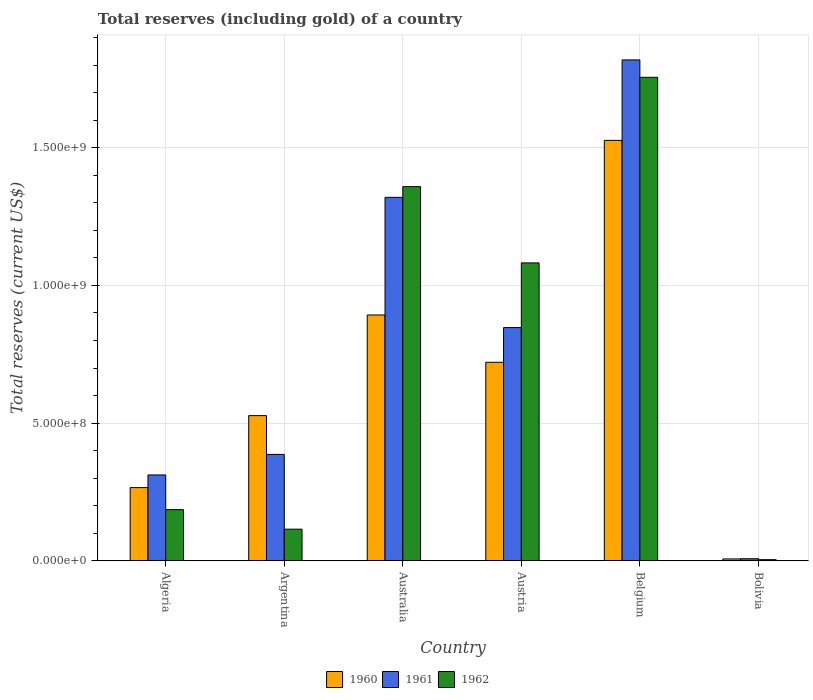How many groups of bars are there?
Your answer should be compact. 6. Are the number of bars per tick equal to the number of legend labels?
Ensure brevity in your answer.  Yes. How many bars are there on the 5th tick from the right?
Your answer should be very brief. 3. What is the label of the 1st group of bars from the left?
Make the answer very short. Algeria. In how many cases, is the number of bars for a given country not equal to the number of legend labels?
Keep it short and to the point. 0. What is the total reserves (including gold) in 1960 in Algeria?
Your response must be concise. 2.66e+08. Across all countries, what is the maximum total reserves (including gold) in 1960?
Your answer should be very brief. 1.53e+09. Across all countries, what is the minimum total reserves (including gold) in 1961?
Your answer should be very brief. 7.40e+06. What is the total total reserves (including gold) in 1962 in the graph?
Your answer should be very brief. 4.50e+09. What is the difference between the total reserves (including gold) in 1961 in Algeria and that in Austria?
Your answer should be compact. -5.35e+08. What is the difference between the total reserves (including gold) in 1962 in Argentina and the total reserves (including gold) in 1960 in Australia?
Your answer should be compact. -7.78e+08. What is the average total reserves (including gold) in 1962 per country?
Provide a short and direct response. 7.50e+08. What is the difference between the total reserves (including gold) of/in 1962 and total reserves (including gold) of/in 1960 in Australia?
Provide a succinct answer. 4.66e+08. In how many countries, is the total reserves (including gold) in 1960 greater than 800000000 US$?
Your answer should be very brief. 2. What is the ratio of the total reserves (including gold) in 1961 in Australia to that in Belgium?
Give a very brief answer. 0.73. Is the total reserves (including gold) in 1962 in Algeria less than that in Australia?
Ensure brevity in your answer.  Yes. What is the difference between the highest and the second highest total reserves (including gold) in 1960?
Keep it short and to the point. -8.06e+08. What is the difference between the highest and the lowest total reserves (including gold) in 1962?
Offer a terse response. 1.75e+09. What does the 2nd bar from the right in Austria represents?
Your answer should be very brief. 1961. Is it the case that in every country, the sum of the total reserves (including gold) in 1960 and total reserves (including gold) in 1961 is greater than the total reserves (including gold) in 1962?
Provide a short and direct response. Yes. How many countries are there in the graph?
Offer a terse response. 6. What is the difference between two consecutive major ticks on the Y-axis?
Ensure brevity in your answer.  5.00e+08. Does the graph contain any zero values?
Make the answer very short. No. What is the title of the graph?
Provide a succinct answer. Total reserves (including gold) of a country. What is the label or title of the Y-axis?
Provide a short and direct response. Total reserves (current US$). What is the Total reserves (current US$) of 1960 in Algeria?
Your answer should be very brief. 2.66e+08. What is the Total reserves (current US$) in 1961 in Algeria?
Provide a short and direct response. 3.12e+08. What is the Total reserves (current US$) in 1962 in Algeria?
Give a very brief answer. 1.86e+08. What is the Total reserves (current US$) of 1960 in Argentina?
Your answer should be compact. 5.27e+08. What is the Total reserves (current US$) of 1961 in Argentina?
Provide a short and direct response. 3.86e+08. What is the Total reserves (current US$) of 1962 in Argentina?
Give a very brief answer. 1.15e+08. What is the Total reserves (current US$) of 1960 in Australia?
Your answer should be very brief. 8.93e+08. What is the Total reserves (current US$) of 1961 in Australia?
Provide a succinct answer. 1.32e+09. What is the Total reserves (current US$) in 1962 in Australia?
Give a very brief answer. 1.36e+09. What is the Total reserves (current US$) of 1960 in Austria?
Your response must be concise. 7.21e+08. What is the Total reserves (current US$) in 1961 in Austria?
Offer a very short reply. 8.47e+08. What is the Total reserves (current US$) of 1962 in Austria?
Provide a short and direct response. 1.08e+09. What is the Total reserves (current US$) in 1960 in Belgium?
Give a very brief answer. 1.53e+09. What is the Total reserves (current US$) of 1961 in Belgium?
Keep it short and to the point. 1.82e+09. What is the Total reserves (current US$) in 1962 in Belgium?
Ensure brevity in your answer.  1.76e+09. What is the Total reserves (current US$) of 1960 in Bolivia?
Give a very brief answer. 6.72e+06. What is the Total reserves (current US$) in 1961 in Bolivia?
Provide a succinct answer. 7.40e+06. What is the Total reserves (current US$) of 1962 in Bolivia?
Give a very brief answer. 4.01e+06. Across all countries, what is the maximum Total reserves (current US$) in 1960?
Your answer should be compact. 1.53e+09. Across all countries, what is the maximum Total reserves (current US$) in 1961?
Your answer should be compact. 1.82e+09. Across all countries, what is the maximum Total reserves (current US$) in 1962?
Provide a short and direct response. 1.76e+09. Across all countries, what is the minimum Total reserves (current US$) in 1960?
Make the answer very short. 6.72e+06. Across all countries, what is the minimum Total reserves (current US$) in 1961?
Give a very brief answer. 7.40e+06. Across all countries, what is the minimum Total reserves (current US$) of 1962?
Keep it short and to the point. 4.01e+06. What is the total Total reserves (current US$) of 1960 in the graph?
Ensure brevity in your answer.  3.94e+09. What is the total Total reserves (current US$) in 1961 in the graph?
Keep it short and to the point. 4.69e+09. What is the total Total reserves (current US$) of 1962 in the graph?
Provide a short and direct response. 4.50e+09. What is the difference between the Total reserves (current US$) of 1960 in Algeria and that in Argentina?
Provide a short and direct response. -2.61e+08. What is the difference between the Total reserves (current US$) of 1961 in Algeria and that in Argentina?
Provide a succinct answer. -7.47e+07. What is the difference between the Total reserves (current US$) in 1962 in Algeria and that in Argentina?
Offer a terse response. 7.10e+07. What is the difference between the Total reserves (current US$) in 1960 in Algeria and that in Australia?
Ensure brevity in your answer.  -6.27e+08. What is the difference between the Total reserves (current US$) of 1961 in Algeria and that in Australia?
Keep it short and to the point. -1.01e+09. What is the difference between the Total reserves (current US$) in 1962 in Algeria and that in Australia?
Make the answer very short. -1.17e+09. What is the difference between the Total reserves (current US$) in 1960 in Algeria and that in Austria?
Provide a short and direct response. -4.55e+08. What is the difference between the Total reserves (current US$) in 1961 in Algeria and that in Austria?
Offer a terse response. -5.35e+08. What is the difference between the Total reserves (current US$) of 1962 in Algeria and that in Austria?
Give a very brief answer. -8.96e+08. What is the difference between the Total reserves (current US$) of 1960 in Algeria and that in Belgium?
Your answer should be very brief. -1.26e+09. What is the difference between the Total reserves (current US$) in 1961 in Algeria and that in Belgium?
Offer a terse response. -1.51e+09. What is the difference between the Total reserves (current US$) of 1962 in Algeria and that in Belgium?
Keep it short and to the point. -1.57e+09. What is the difference between the Total reserves (current US$) in 1960 in Algeria and that in Bolivia?
Your response must be concise. 2.59e+08. What is the difference between the Total reserves (current US$) of 1961 in Algeria and that in Bolivia?
Ensure brevity in your answer.  3.04e+08. What is the difference between the Total reserves (current US$) of 1962 in Algeria and that in Bolivia?
Give a very brief answer. 1.82e+08. What is the difference between the Total reserves (current US$) in 1960 in Argentina and that in Australia?
Your answer should be compact. -3.66e+08. What is the difference between the Total reserves (current US$) in 1961 in Argentina and that in Australia?
Ensure brevity in your answer.  -9.34e+08. What is the difference between the Total reserves (current US$) of 1962 in Argentina and that in Australia?
Your response must be concise. -1.24e+09. What is the difference between the Total reserves (current US$) in 1960 in Argentina and that in Austria?
Provide a succinct answer. -1.94e+08. What is the difference between the Total reserves (current US$) in 1961 in Argentina and that in Austria?
Your answer should be very brief. -4.61e+08. What is the difference between the Total reserves (current US$) of 1962 in Argentina and that in Austria?
Keep it short and to the point. -9.67e+08. What is the difference between the Total reserves (current US$) in 1960 in Argentina and that in Belgium?
Ensure brevity in your answer.  -1.00e+09. What is the difference between the Total reserves (current US$) of 1961 in Argentina and that in Belgium?
Your answer should be very brief. -1.43e+09. What is the difference between the Total reserves (current US$) in 1962 in Argentina and that in Belgium?
Keep it short and to the point. -1.64e+09. What is the difference between the Total reserves (current US$) of 1960 in Argentina and that in Bolivia?
Your response must be concise. 5.21e+08. What is the difference between the Total reserves (current US$) of 1961 in Argentina and that in Bolivia?
Provide a short and direct response. 3.79e+08. What is the difference between the Total reserves (current US$) of 1962 in Argentina and that in Bolivia?
Provide a succinct answer. 1.11e+08. What is the difference between the Total reserves (current US$) of 1960 in Australia and that in Austria?
Offer a terse response. 1.72e+08. What is the difference between the Total reserves (current US$) in 1961 in Australia and that in Austria?
Your answer should be compact. 4.73e+08. What is the difference between the Total reserves (current US$) of 1962 in Australia and that in Austria?
Provide a short and direct response. 2.77e+08. What is the difference between the Total reserves (current US$) of 1960 in Australia and that in Belgium?
Your answer should be compact. -6.34e+08. What is the difference between the Total reserves (current US$) in 1961 in Australia and that in Belgium?
Offer a very short reply. -4.99e+08. What is the difference between the Total reserves (current US$) in 1962 in Australia and that in Belgium?
Your answer should be compact. -3.97e+08. What is the difference between the Total reserves (current US$) in 1960 in Australia and that in Bolivia?
Your answer should be compact. 8.86e+08. What is the difference between the Total reserves (current US$) of 1961 in Australia and that in Bolivia?
Provide a short and direct response. 1.31e+09. What is the difference between the Total reserves (current US$) in 1962 in Australia and that in Bolivia?
Offer a very short reply. 1.35e+09. What is the difference between the Total reserves (current US$) in 1960 in Austria and that in Belgium?
Make the answer very short. -8.06e+08. What is the difference between the Total reserves (current US$) in 1961 in Austria and that in Belgium?
Offer a very short reply. -9.72e+08. What is the difference between the Total reserves (current US$) of 1962 in Austria and that in Belgium?
Keep it short and to the point. -6.74e+08. What is the difference between the Total reserves (current US$) in 1960 in Austria and that in Bolivia?
Offer a very short reply. 7.14e+08. What is the difference between the Total reserves (current US$) in 1961 in Austria and that in Bolivia?
Provide a short and direct response. 8.40e+08. What is the difference between the Total reserves (current US$) of 1962 in Austria and that in Bolivia?
Ensure brevity in your answer.  1.08e+09. What is the difference between the Total reserves (current US$) in 1960 in Belgium and that in Bolivia?
Your answer should be very brief. 1.52e+09. What is the difference between the Total reserves (current US$) in 1961 in Belgium and that in Bolivia?
Offer a terse response. 1.81e+09. What is the difference between the Total reserves (current US$) of 1962 in Belgium and that in Bolivia?
Your answer should be compact. 1.75e+09. What is the difference between the Total reserves (current US$) in 1960 in Algeria and the Total reserves (current US$) in 1961 in Argentina?
Keep it short and to the point. -1.21e+08. What is the difference between the Total reserves (current US$) in 1960 in Algeria and the Total reserves (current US$) in 1962 in Argentina?
Make the answer very short. 1.51e+08. What is the difference between the Total reserves (current US$) of 1961 in Algeria and the Total reserves (current US$) of 1962 in Argentina?
Provide a short and direct response. 1.97e+08. What is the difference between the Total reserves (current US$) in 1960 in Algeria and the Total reserves (current US$) in 1961 in Australia?
Offer a very short reply. -1.05e+09. What is the difference between the Total reserves (current US$) in 1960 in Algeria and the Total reserves (current US$) in 1962 in Australia?
Keep it short and to the point. -1.09e+09. What is the difference between the Total reserves (current US$) of 1961 in Algeria and the Total reserves (current US$) of 1962 in Australia?
Offer a terse response. -1.05e+09. What is the difference between the Total reserves (current US$) of 1960 in Algeria and the Total reserves (current US$) of 1961 in Austria?
Offer a terse response. -5.81e+08. What is the difference between the Total reserves (current US$) in 1960 in Algeria and the Total reserves (current US$) in 1962 in Austria?
Your answer should be very brief. -8.16e+08. What is the difference between the Total reserves (current US$) in 1961 in Algeria and the Total reserves (current US$) in 1962 in Austria?
Offer a very short reply. -7.70e+08. What is the difference between the Total reserves (current US$) of 1960 in Algeria and the Total reserves (current US$) of 1961 in Belgium?
Offer a terse response. -1.55e+09. What is the difference between the Total reserves (current US$) in 1960 in Algeria and the Total reserves (current US$) in 1962 in Belgium?
Offer a very short reply. -1.49e+09. What is the difference between the Total reserves (current US$) of 1961 in Algeria and the Total reserves (current US$) of 1962 in Belgium?
Your answer should be very brief. -1.44e+09. What is the difference between the Total reserves (current US$) in 1960 in Algeria and the Total reserves (current US$) in 1961 in Bolivia?
Keep it short and to the point. 2.58e+08. What is the difference between the Total reserves (current US$) in 1960 in Algeria and the Total reserves (current US$) in 1962 in Bolivia?
Offer a very short reply. 2.62e+08. What is the difference between the Total reserves (current US$) of 1961 in Algeria and the Total reserves (current US$) of 1962 in Bolivia?
Your answer should be very brief. 3.08e+08. What is the difference between the Total reserves (current US$) in 1960 in Argentina and the Total reserves (current US$) in 1961 in Australia?
Provide a short and direct response. -7.93e+08. What is the difference between the Total reserves (current US$) in 1960 in Argentina and the Total reserves (current US$) in 1962 in Australia?
Offer a terse response. -8.32e+08. What is the difference between the Total reserves (current US$) of 1961 in Argentina and the Total reserves (current US$) of 1962 in Australia?
Provide a succinct answer. -9.73e+08. What is the difference between the Total reserves (current US$) of 1960 in Argentina and the Total reserves (current US$) of 1961 in Austria?
Offer a terse response. -3.20e+08. What is the difference between the Total reserves (current US$) in 1960 in Argentina and the Total reserves (current US$) in 1962 in Austria?
Your response must be concise. -5.55e+08. What is the difference between the Total reserves (current US$) of 1961 in Argentina and the Total reserves (current US$) of 1962 in Austria?
Offer a terse response. -6.96e+08. What is the difference between the Total reserves (current US$) in 1960 in Argentina and the Total reserves (current US$) in 1961 in Belgium?
Provide a succinct answer. -1.29e+09. What is the difference between the Total reserves (current US$) in 1960 in Argentina and the Total reserves (current US$) in 1962 in Belgium?
Ensure brevity in your answer.  -1.23e+09. What is the difference between the Total reserves (current US$) in 1961 in Argentina and the Total reserves (current US$) in 1962 in Belgium?
Your answer should be very brief. -1.37e+09. What is the difference between the Total reserves (current US$) in 1960 in Argentina and the Total reserves (current US$) in 1961 in Bolivia?
Your answer should be compact. 5.20e+08. What is the difference between the Total reserves (current US$) in 1960 in Argentina and the Total reserves (current US$) in 1962 in Bolivia?
Ensure brevity in your answer.  5.23e+08. What is the difference between the Total reserves (current US$) in 1961 in Argentina and the Total reserves (current US$) in 1962 in Bolivia?
Provide a succinct answer. 3.82e+08. What is the difference between the Total reserves (current US$) in 1960 in Australia and the Total reserves (current US$) in 1961 in Austria?
Offer a terse response. 4.57e+07. What is the difference between the Total reserves (current US$) of 1960 in Australia and the Total reserves (current US$) of 1962 in Austria?
Give a very brief answer. -1.89e+08. What is the difference between the Total reserves (current US$) in 1961 in Australia and the Total reserves (current US$) in 1962 in Austria?
Your answer should be compact. 2.38e+08. What is the difference between the Total reserves (current US$) of 1960 in Australia and the Total reserves (current US$) of 1961 in Belgium?
Your answer should be compact. -9.26e+08. What is the difference between the Total reserves (current US$) in 1960 in Australia and the Total reserves (current US$) in 1962 in Belgium?
Provide a succinct answer. -8.63e+08. What is the difference between the Total reserves (current US$) of 1961 in Australia and the Total reserves (current US$) of 1962 in Belgium?
Make the answer very short. -4.36e+08. What is the difference between the Total reserves (current US$) of 1960 in Australia and the Total reserves (current US$) of 1961 in Bolivia?
Make the answer very short. 8.85e+08. What is the difference between the Total reserves (current US$) in 1960 in Australia and the Total reserves (current US$) in 1962 in Bolivia?
Offer a terse response. 8.89e+08. What is the difference between the Total reserves (current US$) in 1961 in Australia and the Total reserves (current US$) in 1962 in Bolivia?
Provide a short and direct response. 1.32e+09. What is the difference between the Total reserves (current US$) of 1960 in Austria and the Total reserves (current US$) of 1961 in Belgium?
Your answer should be compact. -1.10e+09. What is the difference between the Total reserves (current US$) of 1960 in Austria and the Total reserves (current US$) of 1962 in Belgium?
Your answer should be very brief. -1.04e+09. What is the difference between the Total reserves (current US$) in 1961 in Austria and the Total reserves (current US$) in 1962 in Belgium?
Give a very brief answer. -9.09e+08. What is the difference between the Total reserves (current US$) in 1960 in Austria and the Total reserves (current US$) in 1961 in Bolivia?
Provide a succinct answer. 7.14e+08. What is the difference between the Total reserves (current US$) of 1960 in Austria and the Total reserves (current US$) of 1962 in Bolivia?
Make the answer very short. 7.17e+08. What is the difference between the Total reserves (current US$) of 1961 in Austria and the Total reserves (current US$) of 1962 in Bolivia?
Give a very brief answer. 8.43e+08. What is the difference between the Total reserves (current US$) in 1960 in Belgium and the Total reserves (current US$) in 1961 in Bolivia?
Offer a very short reply. 1.52e+09. What is the difference between the Total reserves (current US$) of 1960 in Belgium and the Total reserves (current US$) of 1962 in Bolivia?
Ensure brevity in your answer.  1.52e+09. What is the difference between the Total reserves (current US$) in 1961 in Belgium and the Total reserves (current US$) in 1962 in Bolivia?
Make the answer very short. 1.82e+09. What is the average Total reserves (current US$) in 1960 per country?
Keep it short and to the point. 6.57e+08. What is the average Total reserves (current US$) of 1961 per country?
Offer a terse response. 7.82e+08. What is the average Total reserves (current US$) of 1962 per country?
Ensure brevity in your answer.  7.50e+08. What is the difference between the Total reserves (current US$) of 1960 and Total reserves (current US$) of 1961 in Algeria?
Ensure brevity in your answer.  -4.59e+07. What is the difference between the Total reserves (current US$) of 1960 and Total reserves (current US$) of 1962 in Algeria?
Provide a succinct answer. 8.01e+07. What is the difference between the Total reserves (current US$) of 1961 and Total reserves (current US$) of 1962 in Algeria?
Give a very brief answer. 1.26e+08. What is the difference between the Total reserves (current US$) in 1960 and Total reserves (current US$) in 1961 in Argentina?
Make the answer very short. 1.41e+08. What is the difference between the Total reserves (current US$) of 1960 and Total reserves (current US$) of 1962 in Argentina?
Your response must be concise. 4.12e+08. What is the difference between the Total reserves (current US$) of 1961 and Total reserves (current US$) of 1962 in Argentina?
Ensure brevity in your answer.  2.72e+08. What is the difference between the Total reserves (current US$) of 1960 and Total reserves (current US$) of 1961 in Australia?
Your answer should be compact. -4.27e+08. What is the difference between the Total reserves (current US$) of 1960 and Total reserves (current US$) of 1962 in Australia?
Your response must be concise. -4.66e+08. What is the difference between the Total reserves (current US$) of 1961 and Total reserves (current US$) of 1962 in Australia?
Make the answer very short. -3.89e+07. What is the difference between the Total reserves (current US$) of 1960 and Total reserves (current US$) of 1961 in Austria?
Offer a terse response. -1.26e+08. What is the difference between the Total reserves (current US$) in 1960 and Total reserves (current US$) in 1962 in Austria?
Ensure brevity in your answer.  -3.61e+08. What is the difference between the Total reserves (current US$) in 1961 and Total reserves (current US$) in 1962 in Austria?
Provide a short and direct response. -2.35e+08. What is the difference between the Total reserves (current US$) in 1960 and Total reserves (current US$) in 1961 in Belgium?
Your response must be concise. -2.92e+08. What is the difference between the Total reserves (current US$) in 1960 and Total reserves (current US$) in 1962 in Belgium?
Your answer should be very brief. -2.29e+08. What is the difference between the Total reserves (current US$) of 1961 and Total reserves (current US$) of 1962 in Belgium?
Your response must be concise. 6.32e+07. What is the difference between the Total reserves (current US$) in 1960 and Total reserves (current US$) in 1961 in Bolivia?
Give a very brief answer. -6.89e+05. What is the difference between the Total reserves (current US$) of 1960 and Total reserves (current US$) of 1962 in Bolivia?
Provide a succinct answer. 2.71e+06. What is the difference between the Total reserves (current US$) in 1961 and Total reserves (current US$) in 1962 in Bolivia?
Ensure brevity in your answer.  3.40e+06. What is the ratio of the Total reserves (current US$) in 1960 in Algeria to that in Argentina?
Ensure brevity in your answer.  0.5. What is the ratio of the Total reserves (current US$) in 1961 in Algeria to that in Argentina?
Your response must be concise. 0.81. What is the ratio of the Total reserves (current US$) in 1962 in Algeria to that in Argentina?
Provide a short and direct response. 1.62. What is the ratio of the Total reserves (current US$) in 1960 in Algeria to that in Australia?
Your answer should be very brief. 0.3. What is the ratio of the Total reserves (current US$) of 1961 in Algeria to that in Australia?
Keep it short and to the point. 0.24. What is the ratio of the Total reserves (current US$) in 1962 in Algeria to that in Australia?
Your answer should be very brief. 0.14. What is the ratio of the Total reserves (current US$) in 1960 in Algeria to that in Austria?
Make the answer very short. 0.37. What is the ratio of the Total reserves (current US$) in 1961 in Algeria to that in Austria?
Provide a succinct answer. 0.37. What is the ratio of the Total reserves (current US$) in 1962 in Algeria to that in Austria?
Keep it short and to the point. 0.17. What is the ratio of the Total reserves (current US$) of 1960 in Algeria to that in Belgium?
Provide a short and direct response. 0.17. What is the ratio of the Total reserves (current US$) of 1961 in Algeria to that in Belgium?
Your response must be concise. 0.17. What is the ratio of the Total reserves (current US$) of 1962 in Algeria to that in Belgium?
Provide a short and direct response. 0.11. What is the ratio of the Total reserves (current US$) of 1960 in Algeria to that in Bolivia?
Your response must be concise. 39.58. What is the ratio of the Total reserves (current US$) in 1961 in Algeria to that in Bolivia?
Keep it short and to the point. 42.1. What is the ratio of the Total reserves (current US$) in 1962 in Algeria to that in Bolivia?
Offer a terse response. 46.36. What is the ratio of the Total reserves (current US$) in 1960 in Argentina to that in Australia?
Provide a short and direct response. 0.59. What is the ratio of the Total reserves (current US$) of 1961 in Argentina to that in Australia?
Offer a terse response. 0.29. What is the ratio of the Total reserves (current US$) in 1962 in Argentina to that in Australia?
Provide a short and direct response. 0.08. What is the ratio of the Total reserves (current US$) in 1960 in Argentina to that in Austria?
Make the answer very short. 0.73. What is the ratio of the Total reserves (current US$) in 1961 in Argentina to that in Austria?
Ensure brevity in your answer.  0.46. What is the ratio of the Total reserves (current US$) of 1962 in Argentina to that in Austria?
Offer a terse response. 0.11. What is the ratio of the Total reserves (current US$) in 1960 in Argentina to that in Belgium?
Provide a succinct answer. 0.35. What is the ratio of the Total reserves (current US$) in 1961 in Argentina to that in Belgium?
Your response must be concise. 0.21. What is the ratio of the Total reserves (current US$) of 1962 in Argentina to that in Belgium?
Offer a terse response. 0.07. What is the ratio of the Total reserves (current US$) of 1960 in Argentina to that in Bolivia?
Give a very brief answer. 78.51. What is the ratio of the Total reserves (current US$) in 1961 in Argentina to that in Bolivia?
Your answer should be compact. 52.19. What is the ratio of the Total reserves (current US$) in 1962 in Argentina to that in Bolivia?
Provide a succinct answer. 28.64. What is the ratio of the Total reserves (current US$) of 1960 in Australia to that in Austria?
Your answer should be very brief. 1.24. What is the ratio of the Total reserves (current US$) of 1961 in Australia to that in Austria?
Offer a terse response. 1.56. What is the ratio of the Total reserves (current US$) in 1962 in Australia to that in Austria?
Give a very brief answer. 1.26. What is the ratio of the Total reserves (current US$) in 1960 in Australia to that in Belgium?
Provide a succinct answer. 0.58. What is the ratio of the Total reserves (current US$) of 1961 in Australia to that in Belgium?
Your answer should be compact. 0.73. What is the ratio of the Total reserves (current US$) of 1962 in Australia to that in Belgium?
Provide a succinct answer. 0.77. What is the ratio of the Total reserves (current US$) of 1960 in Australia to that in Bolivia?
Give a very brief answer. 132.95. What is the ratio of the Total reserves (current US$) in 1961 in Australia to that in Bolivia?
Make the answer very short. 178.28. What is the ratio of the Total reserves (current US$) of 1962 in Australia to that in Bolivia?
Your answer should be very brief. 339.23. What is the ratio of the Total reserves (current US$) of 1960 in Austria to that in Belgium?
Provide a short and direct response. 0.47. What is the ratio of the Total reserves (current US$) of 1961 in Austria to that in Belgium?
Your answer should be very brief. 0.47. What is the ratio of the Total reserves (current US$) of 1962 in Austria to that in Belgium?
Your response must be concise. 0.62. What is the ratio of the Total reserves (current US$) of 1960 in Austria to that in Bolivia?
Give a very brief answer. 107.36. What is the ratio of the Total reserves (current US$) in 1961 in Austria to that in Bolivia?
Ensure brevity in your answer.  114.4. What is the ratio of the Total reserves (current US$) of 1962 in Austria to that in Bolivia?
Keep it short and to the point. 270.08. What is the ratio of the Total reserves (current US$) of 1960 in Belgium to that in Bolivia?
Provide a succinct answer. 227.38. What is the ratio of the Total reserves (current US$) of 1961 in Belgium to that in Bolivia?
Your answer should be compact. 245.7. What is the ratio of the Total reserves (current US$) of 1962 in Belgium to that in Bolivia?
Your answer should be very brief. 438.36. What is the difference between the highest and the second highest Total reserves (current US$) in 1960?
Keep it short and to the point. 6.34e+08. What is the difference between the highest and the second highest Total reserves (current US$) of 1961?
Offer a very short reply. 4.99e+08. What is the difference between the highest and the second highest Total reserves (current US$) of 1962?
Your answer should be very brief. 3.97e+08. What is the difference between the highest and the lowest Total reserves (current US$) of 1960?
Your answer should be very brief. 1.52e+09. What is the difference between the highest and the lowest Total reserves (current US$) of 1961?
Your response must be concise. 1.81e+09. What is the difference between the highest and the lowest Total reserves (current US$) in 1962?
Your answer should be compact. 1.75e+09. 